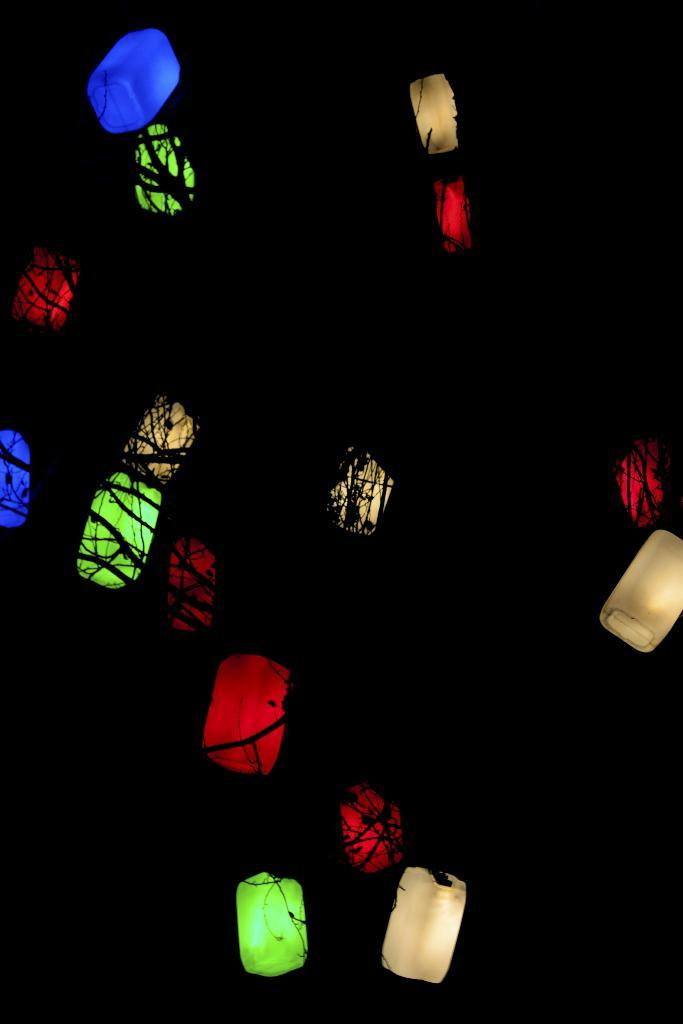What can be seen in the image that provides illumination? There are lights in the image. How many times does the person in the image blow out the middle bit of the candle? There is no person or candle present in the image, so this question cannot be answered. 